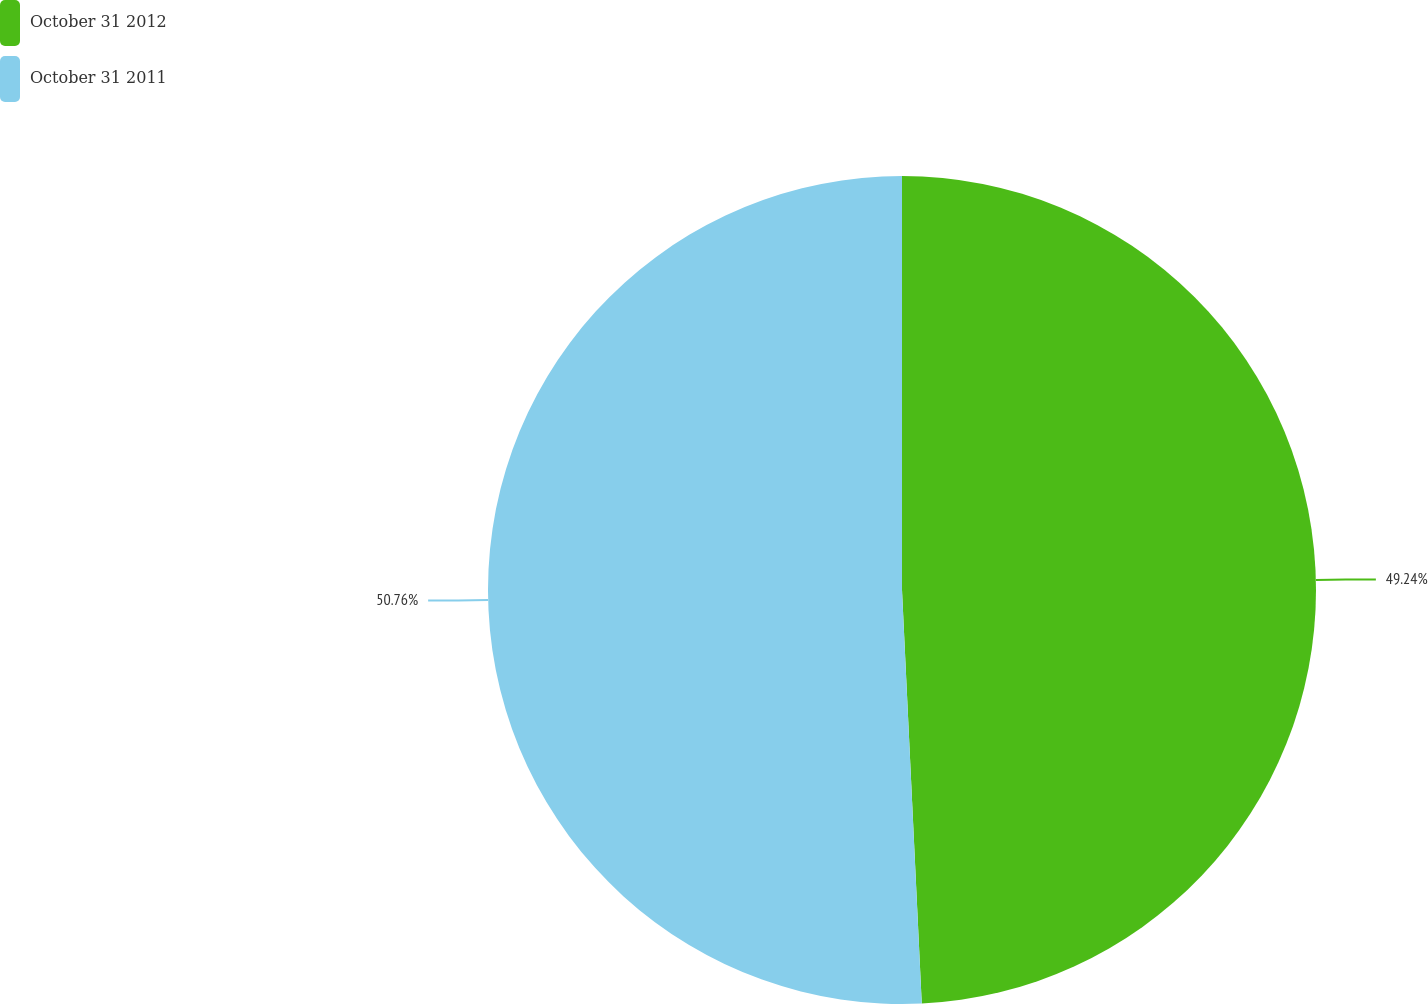Convert chart. <chart><loc_0><loc_0><loc_500><loc_500><pie_chart><fcel>October 31 2012<fcel>October 31 2011<nl><fcel>49.24%<fcel>50.76%<nl></chart> 